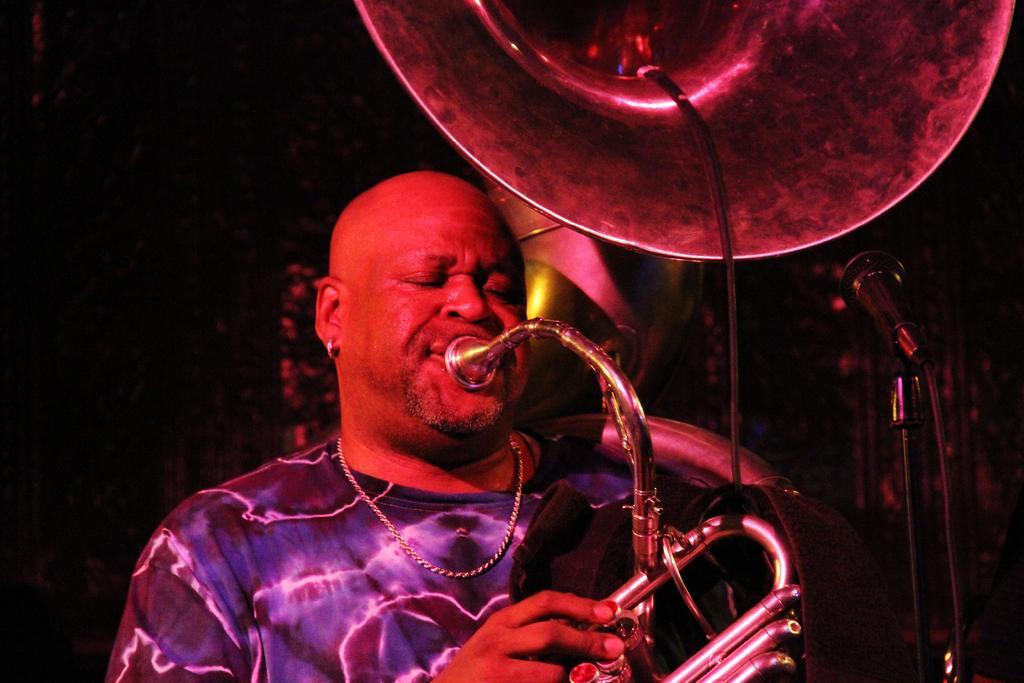Can you describe this image briefly? In this image there is a man playing trumpet. He is wearing a chain and earring. In front of him there is a microphone and microphone stand. The background is dark. 